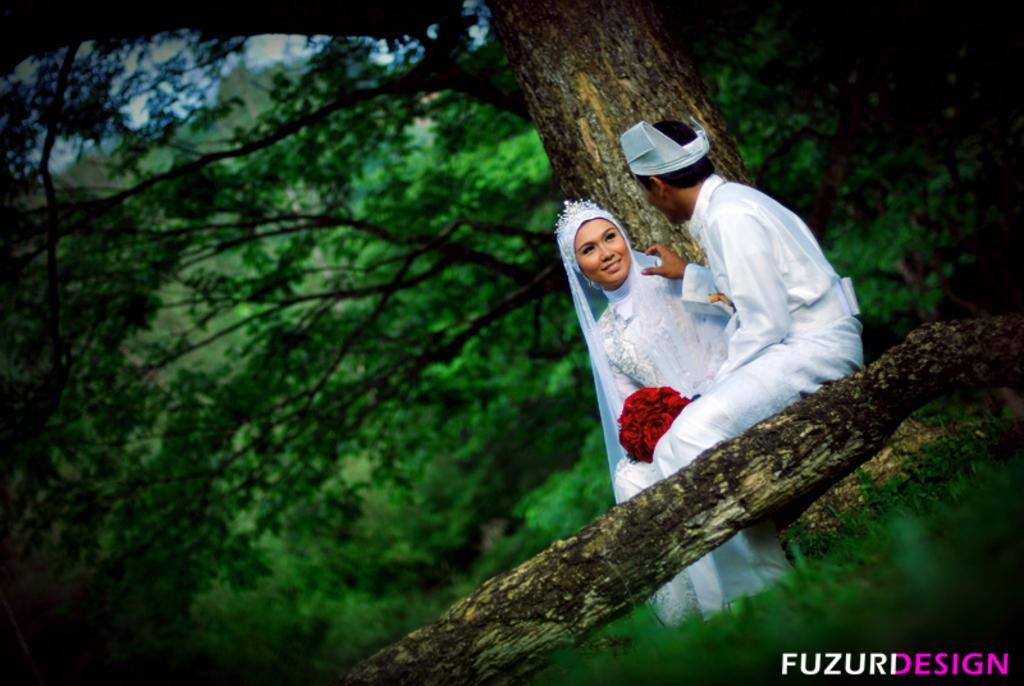Can you describe this image briefly? In this image there is a man and a woman holding a flower bouquet are sitting on the branch of a tree, behind them there are trees, at the bottom of the image there is some text. 